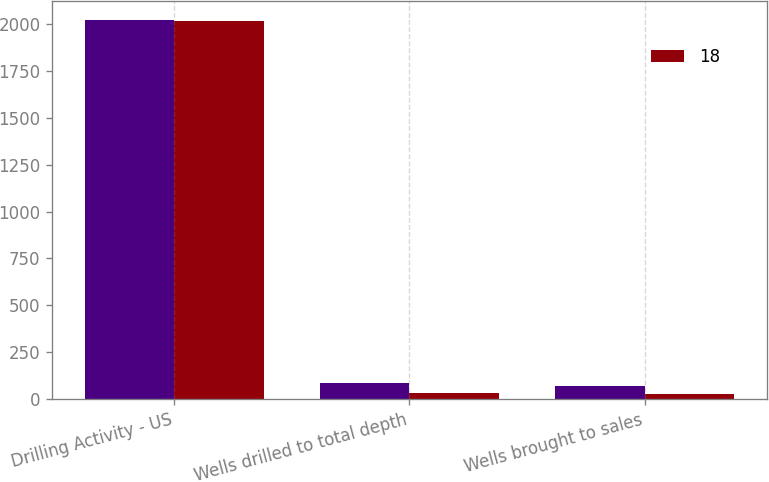Convert chart to OTSL. <chart><loc_0><loc_0><loc_500><loc_500><stacked_bar_chart><ecel><fcel>Drilling Activity - US<fcel>Wells drilled to total depth<fcel>Wells brought to sales<nl><fcel>nan<fcel>2017<fcel>86<fcel>73<nl><fcel>18<fcel>2016<fcel>33<fcel>28<nl></chart> 